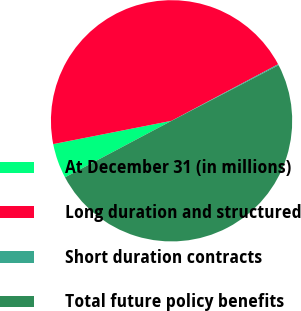<chart> <loc_0><loc_0><loc_500><loc_500><pie_chart><fcel>At December 31 (in millions)<fcel>Long duration and structured<fcel>Short duration contracts<fcel>Total future policy benefits<nl><fcel>4.67%<fcel>45.33%<fcel>0.14%<fcel>49.86%<nl></chart> 